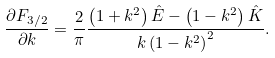Convert formula to latex. <formula><loc_0><loc_0><loc_500><loc_500>\frac { { \partial F _ { 3 / 2 } } } { \partial k } = \frac { 2 } { \pi } \frac { { \left ( 1 + k ^ { 2 } \right ) \hat { E } - \left ( 1 - k ^ { 2 } \right ) \hat { K } } } { k \left ( 1 - k ^ { 2 } \right ) ^ { 2 } } .</formula> 